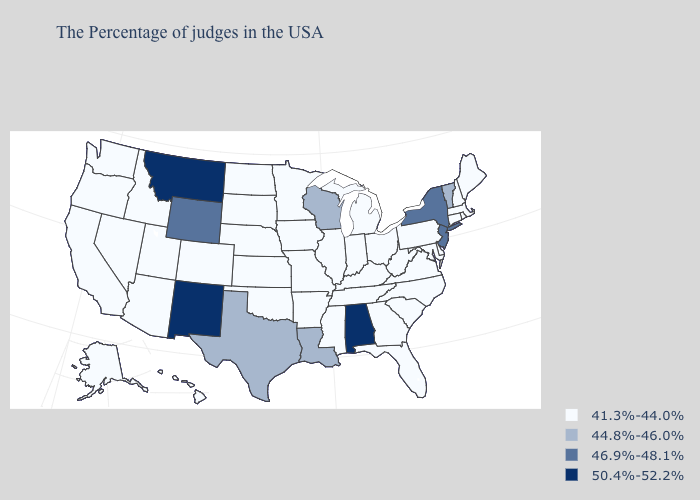Which states hav the highest value in the Northeast?
Keep it brief. New York, New Jersey. Does the first symbol in the legend represent the smallest category?
Short answer required. Yes. What is the highest value in the USA?
Quick response, please. 50.4%-52.2%. Does Arizona have the highest value in the USA?
Give a very brief answer. No. What is the value of New Hampshire?
Give a very brief answer. 41.3%-44.0%. Does Minnesota have the highest value in the USA?
Keep it brief. No. Does the map have missing data?
Keep it brief. No. Name the states that have a value in the range 44.8%-46.0%?
Concise answer only. Vermont, Wisconsin, Louisiana, Texas. Does Utah have the lowest value in the West?
Keep it brief. Yes. What is the value of Delaware?
Quick response, please. 41.3%-44.0%. Which states have the lowest value in the USA?
Write a very short answer. Maine, Massachusetts, Rhode Island, New Hampshire, Connecticut, Delaware, Maryland, Pennsylvania, Virginia, North Carolina, South Carolina, West Virginia, Ohio, Florida, Georgia, Michigan, Kentucky, Indiana, Tennessee, Illinois, Mississippi, Missouri, Arkansas, Minnesota, Iowa, Kansas, Nebraska, Oklahoma, South Dakota, North Dakota, Colorado, Utah, Arizona, Idaho, Nevada, California, Washington, Oregon, Alaska, Hawaii. Which states have the lowest value in the South?
Short answer required. Delaware, Maryland, Virginia, North Carolina, South Carolina, West Virginia, Florida, Georgia, Kentucky, Tennessee, Mississippi, Arkansas, Oklahoma. Among the states that border Wyoming , does Montana have the highest value?
Give a very brief answer. Yes. Does North Carolina have a lower value than Vermont?
Quick response, please. Yes. Name the states that have a value in the range 41.3%-44.0%?
Write a very short answer. Maine, Massachusetts, Rhode Island, New Hampshire, Connecticut, Delaware, Maryland, Pennsylvania, Virginia, North Carolina, South Carolina, West Virginia, Ohio, Florida, Georgia, Michigan, Kentucky, Indiana, Tennessee, Illinois, Mississippi, Missouri, Arkansas, Minnesota, Iowa, Kansas, Nebraska, Oklahoma, South Dakota, North Dakota, Colorado, Utah, Arizona, Idaho, Nevada, California, Washington, Oregon, Alaska, Hawaii. 